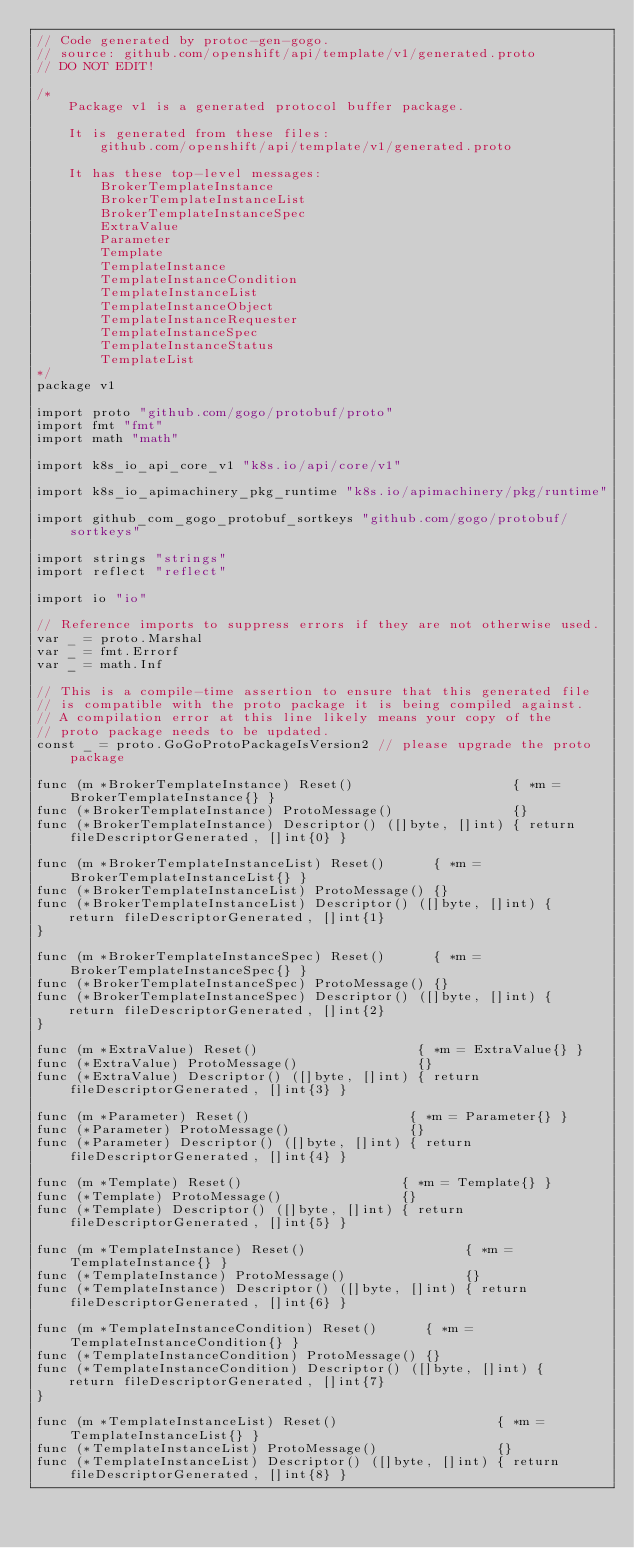<code> <loc_0><loc_0><loc_500><loc_500><_Go_>// Code generated by protoc-gen-gogo.
// source: github.com/openshift/api/template/v1/generated.proto
// DO NOT EDIT!

/*
	Package v1 is a generated protocol buffer package.

	It is generated from these files:
		github.com/openshift/api/template/v1/generated.proto

	It has these top-level messages:
		BrokerTemplateInstance
		BrokerTemplateInstanceList
		BrokerTemplateInstanceSpec
		ExtraValue
		Parameter
		Template
		TemplateInstance
		TemplateInstanceCondition
		TemplateInstanceList
		TemplateInstanceObject
		TemplateInstanceRequester
		TemplateInstanceSpec
		TemplateInstanceStatus
		TemplateList
*/
package v1

import proto "github.com/gogo/protobuf/proto"
import fmt "fmt"
import math "math"

import k8s_io_api_core_v1 "k8s.io/api/core/v1"

import k8s_io_apimachinery_pkg_runtime "k8s.io/apimachinery/pkg/runtime"

import github_com_gogo_protobuf_sortkeys "github.com/gogo/protobuf/sortkeys"

import strings "strings"
import reflect "reflect"

import io "io"

// Reference imports to suppress errors if they are not otherwise used.
var _ = proto.Marshal
var _ = fmt.Errorf
var _ = math.Inf

// This is a compile-time assertion to ensure that this generated file
// is compatible with the proto package it is being compiled against.
// A compilation error at this line likely means your copy of the
// proto package needs to be updated.
const _ = proto.GoGoProtoPackageIsVersion2 // please upgrade the proto package

func (m *BrokerTemplateInstance) Reset()                    { *m = BrokerTemplateInstance{} }
func (*BrokerTemplateInstance) ProtoMessage()               {}
func (*BrokerTemplateInstance) Descriptor() ([]byte, []int) { return fileDescriptorGenerated, []int{0} }

func (m *BrokerTemplateInstanceList) Reset()      { *m = BrokerTemplateInstanceList{} }
func (*BrokerTemplateInstanceList) ProtoMessage() {}
func (*BrokerTemplateInstanceList) Descriptor() ([]byte, []int) {
	return fileDescriptorGenerated, []int{1}
}

func (m *BrokerTemplateInstanceSpec) Reset()      { *m = BrokerTemplateInstanceSpec{} }
func (*BrokerTemplateInstanceSpec) ProtoMessage() {}
func (*BrokerTemplateInstanceSpec) Descriptor() ([]byte, []int) {
	return fileDescriptorGenerated, []int{2}
}

func (m *ExtraValue) Reset()                    { *m = ExtraValue{} }
func (*ExtraValue) ProtoMessage()               {}
func (*ExtraValue) Descriptor() ([]byte, []int) { return fileDescriptorGenerated, []int{3} }

func (m *Parameter) Reset()                    { *m = Parameter{} }
func (*Parameter) ProtoMessage()               {}
func (*Parameter) Descriptor() ([]byte, []int) { return fileDescriptorGenerated, []int{4} }

func (m *Template) Reset()                    { *m = Template{} }
func (*Template) ProtoMessage()               {}
func (*Template) Descriptor() ([]byte, []int) { return fileDescriptorGenerated, []int{5} }

func (m *TemplateInstance) Reset()                    { *m = TemplateInstance{} }
func (*TemplateInstance) ProtoMessage()               {}
func (*TemplateInstance) Descriptor() ([]byte, []int) { return fileDescriptorGenerated, []int{6} }

func (m *TemplateInstanceCondition) Reset()      { *m = TemplateInstanceCondition{} }
func (*TemplateInstanceCondition) ProtoMessage() {}
func (*TemplateInstanceCondition) Descriptor() ([]byte, []int) {
	return fileDescriptorGenerated, []int{7}
}

func (m *TemplateInstanceList) Reset()                    { *m = TemplateInstanceList{} }
func (*TemplateInstanceList) ProtoMessage()               {}
func (*TemplateInstanceList) Descriptor() ([]byte, []int) { return fileDescriptorGenerated, []int{8} }
</code> 